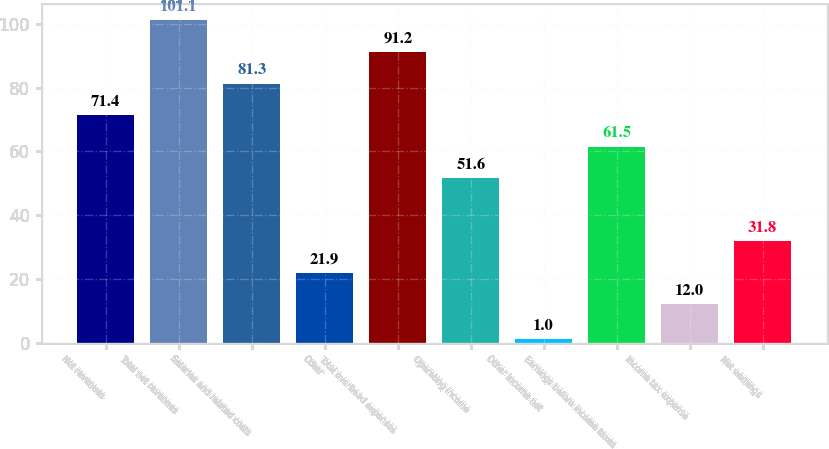<chart> <loc_0><loc_0><loc_500><loc_500><bar_chart><fcel>Net revenues<fcel>Total net revenues<fcel>Salaries and related costs<fcel>Other<fcel>Total overhead expenses<fcel>Operating income<fcel>Other income net<fcel>Earnings before income taxes<fcel>Income tax expense<fcel>Net earnings<nl><fcel>71.4<fcel>101.1<fcel>81.3<fcel>21.9<fcel>91.2<fcel>51.6<fcel>1<fcel>61.5<fcel>12<fcel>31.8<nl></chart> 